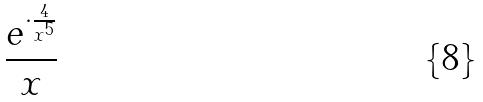Convert formula to latex. <formula><loc_0><loc_0><loc_500><loc_500>\frac { e ^ { \cdot \frac { 4 } { x ^ { 5 } } } } { x }</formula> 